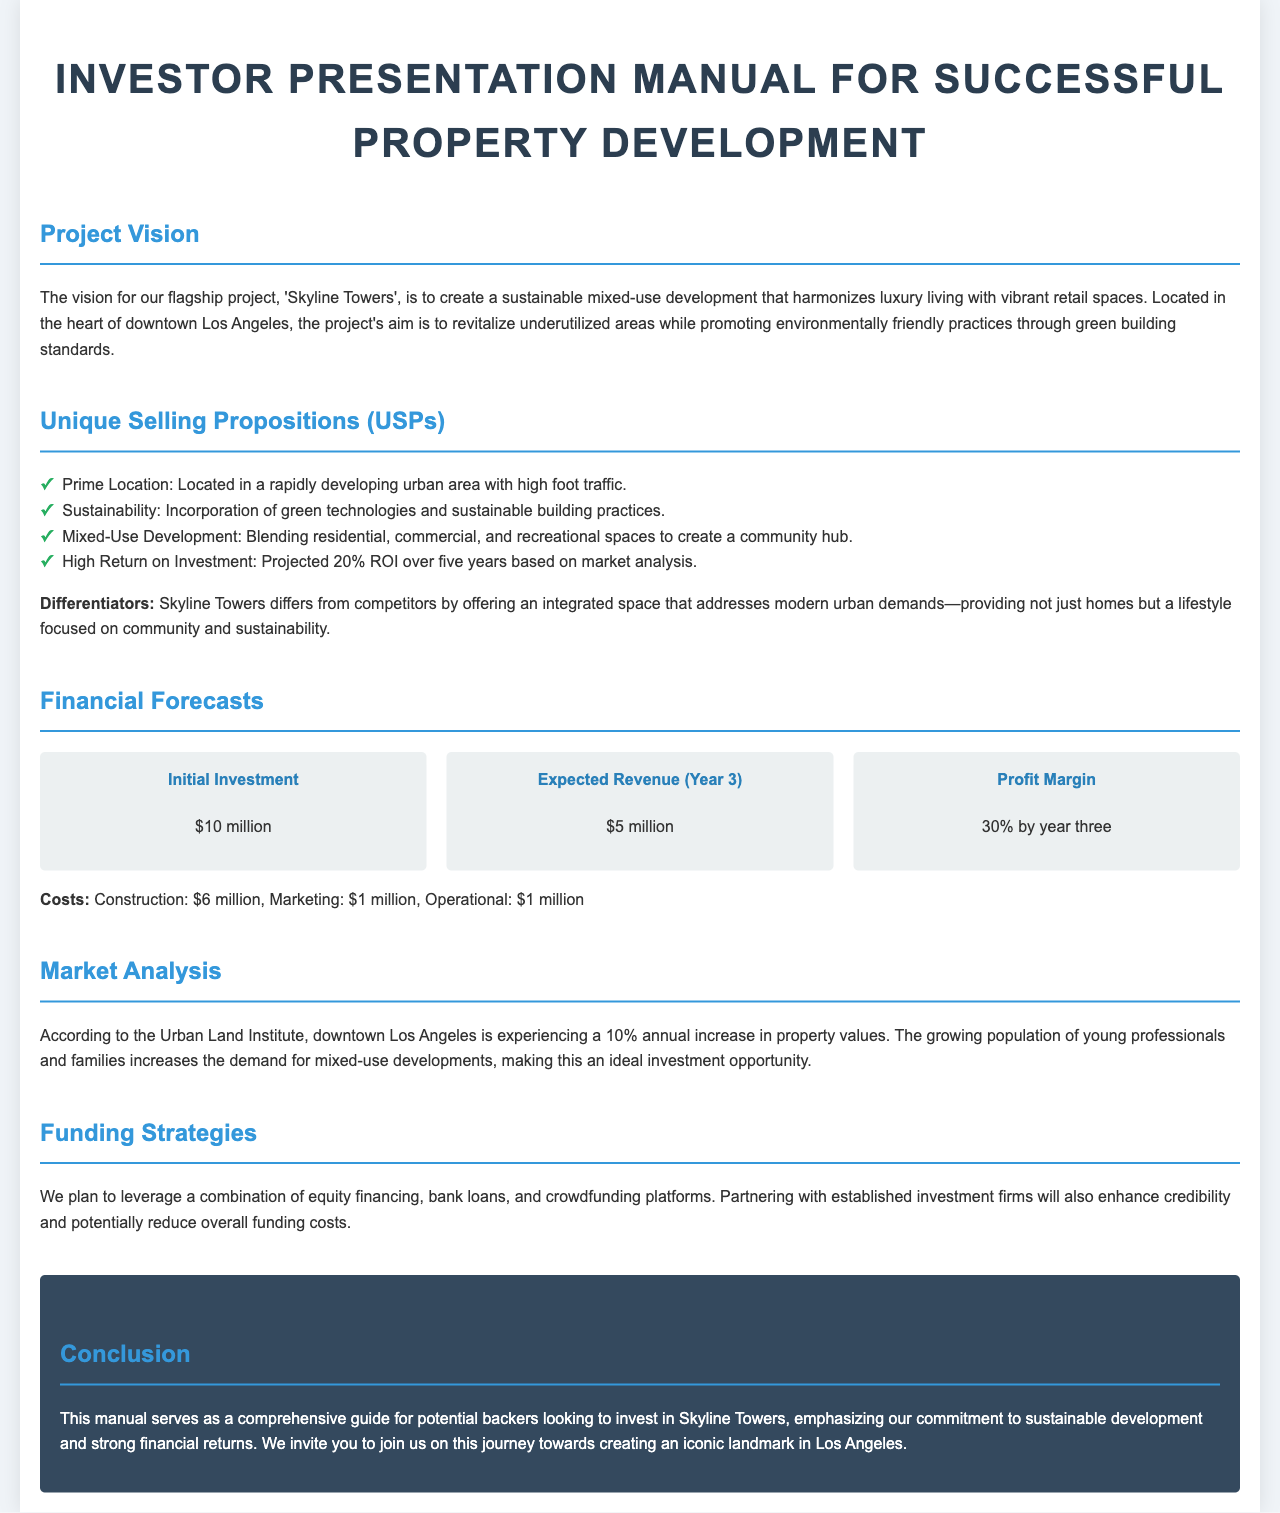What is the project name? The project name is mentioned in the introduction section as 'Skyline Towers'.
Answer: Skyline Towers What is the expected revenue in Year 3? The document lists the expected revenue for Year 3 as stated in the financial forecasts section.
Answer: $5 million What is the profit margin by Year 3? The profit margin is provided in the financial forecasts section, showing expected profitability by that time.
Answer: 30% What is the initial investment amount? The initial investment is explicitly stated in the financial forecasts section of the document.
Answer: $10 million What differentiates Skyline Towers from competitors? The document provides differentiators that set this project apart in the Unique Selling Propositions section.
Answer: Integrated space addressing modern urban demands What is the annual increase in property values according to the market analysis? The document refers to specific statistics in the market analysis section regarding property values.
Answer: 10% Which funding strategies will be used? The funding strategies section describes the methods intended for funding the project.
Answer: Equity financing, bank loans, and crowdfunding platforms What type of development is Skyline Towers? The document indicates the nature of the development in the project vision section.
Answer: Mixed-use development What is the location of the project? The specific location of the project is provided in the project vision section.
Answer: Downtown Los Angeles 